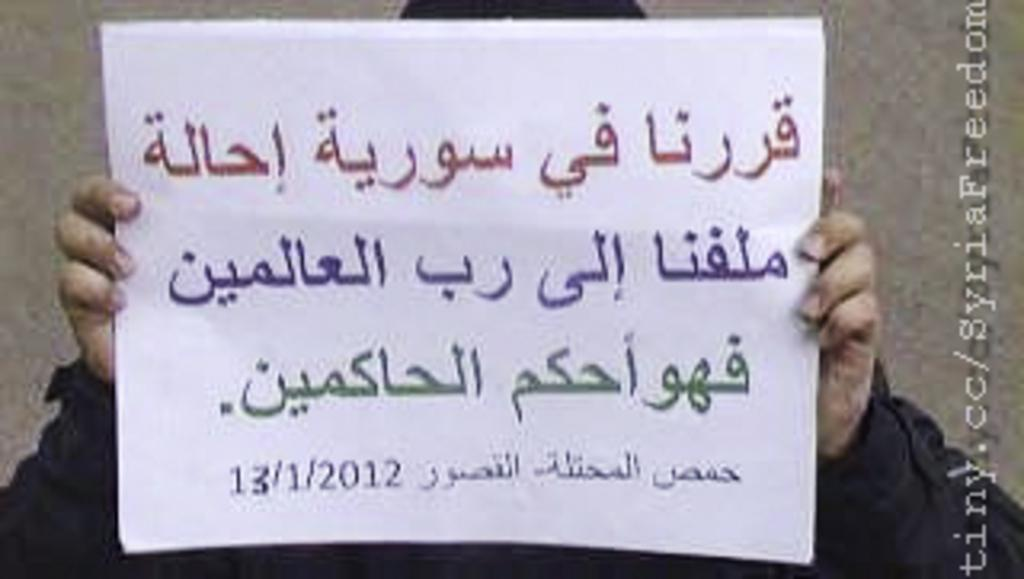<image>
Write a terse but informative summary of the picture. Someone holds a large piece of paper with arabic writing on it dated 13/1/2012 on it. 